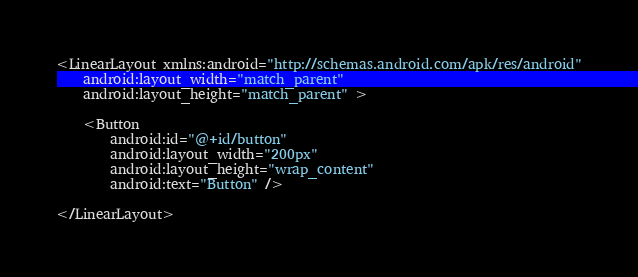Convert code to text. <code><loc_0><loc_0><loc_500><loc_500><_XML_><LinearLayout xmlns:android="http://schemas.android.com/apk/res/android"
    android:layout_width="match_parent"
    android:layout_height="match_parent" >

    <Button
        android:id="@+id/button"
        android:layout_width="200px"
        android:layout_height="wrap_content"
        android:text="Button" />

</LinearLayout></code> 